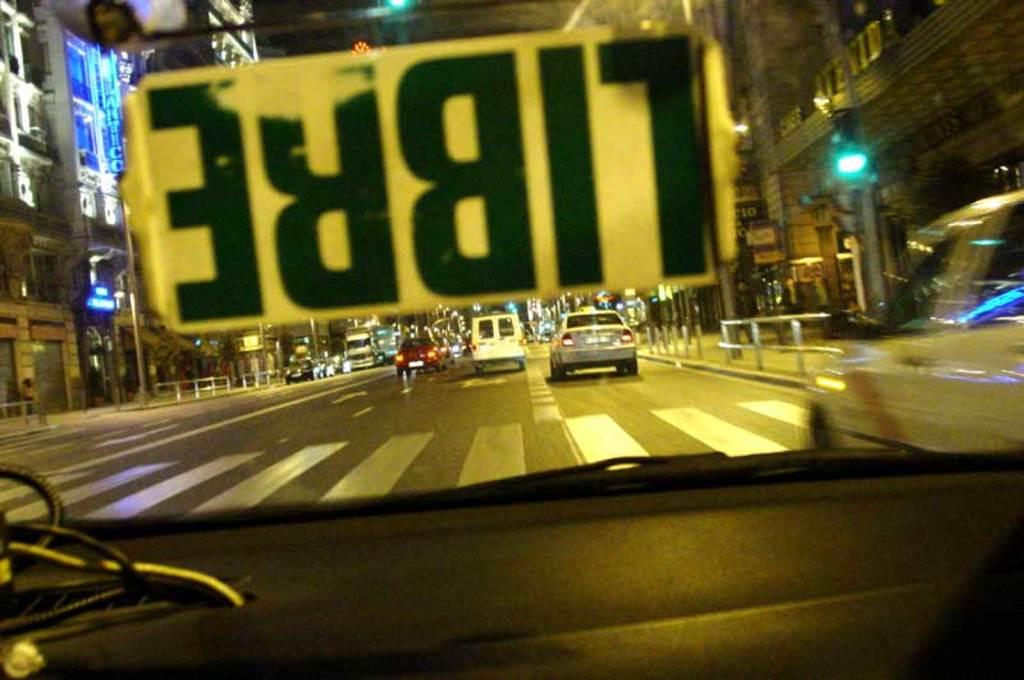<image>
Relay a brief, clear account of the picture shown. A car window has a sticker reading Libre on the windshield. 